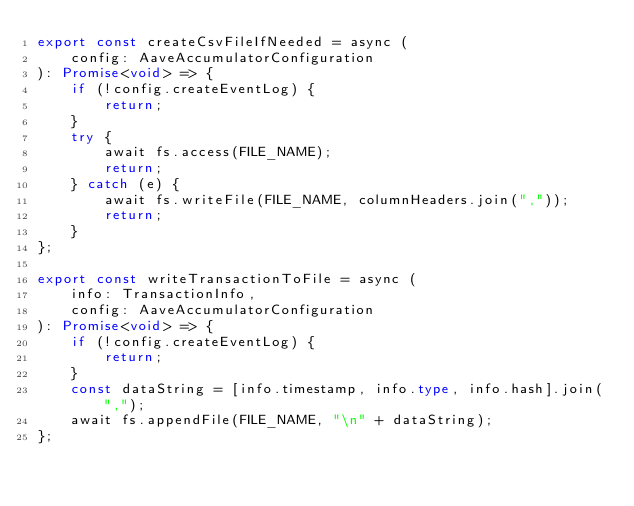<code> <loc_0><loc_0><loc_500><loc_500><_TypeScript_>export const createCsvFileIfNeeded = async (
    config: AaveAccumulatorConfiguration
): Promise<void> => {
    if (!config.createEventLog) {
        return;
    }
    try {
        await fs.access(FILE_NAME);
        return;
    } catch (e) {
        await fs.writeFile(FILE_NAME, columnHeaders.join(","));
        return;
    }
};

export const writeTransactionToFile = async (
    info: TransactionInfo,
    config: AaveAccumulatorConfiguration
): Promise<void> => {
    if (!config.createEventLog) {
        return;
    }
    const dataString = [info.timestamp, info.type, info.hash].join(",");
    await fs.appendFile(FILE_NAME, "\n" + dataString);
};
</code> 